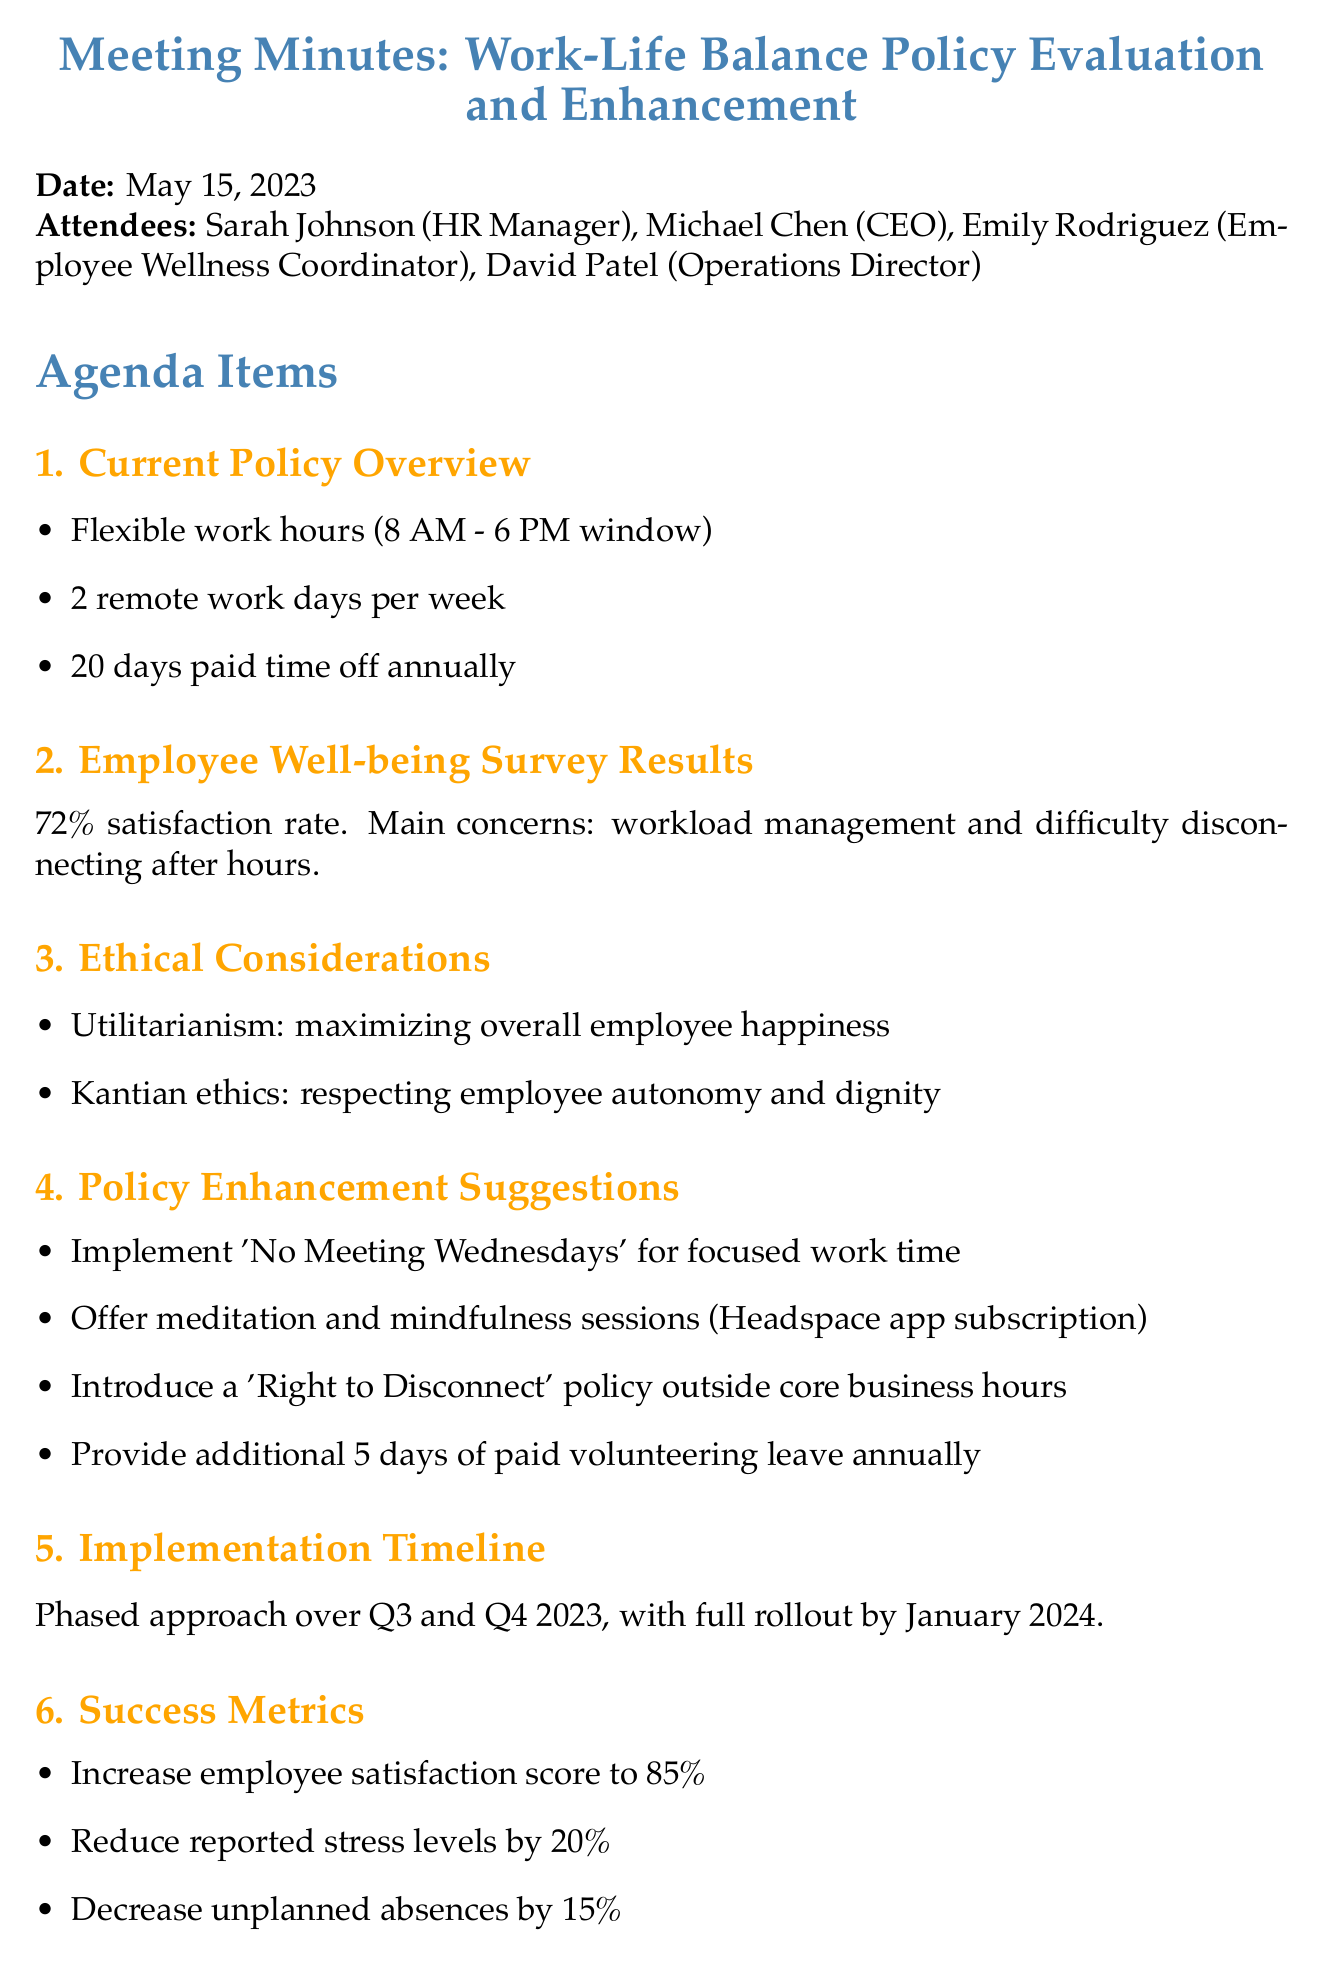What is the date of the meeting? The date of the meeting is mentioned at the beginning of the document.
Answer: May 15, 2023 Who is the HR Manager? The HR Manager's name is listed among the attendees in the document.
Answer: Sarah Johnson What is the employee satisfaction rate? The document provides survey results that highlight the satisfaction rate among employees.
Answer: 72% What is one suggested policy enhancement related to mindfulness? The document lists policy enhancement suggestions, one of which pertains to mindfulness sessions.
Answer: Offer meditation and mindfulness sessions through Headspace app subscription What is the goal for employee satisfaction score? The success metrics section outlines the target for employee satisfaction.
Answer: 85% What ethical principle emphasizes employee autonomy? The ethical considerations section presents various ethical principles, one of which focuses on autonomy.
Answer: Kantian ethics Which month will the full rollout occur? The implementation timeline specifies when the full rollout of the new policies will take place.
Answer: January 2024 How many days of paid volunteering leave are suggested annually? The policy enhancement suggestions include a provision for paid volunteering leave.
Answer: 5 days 